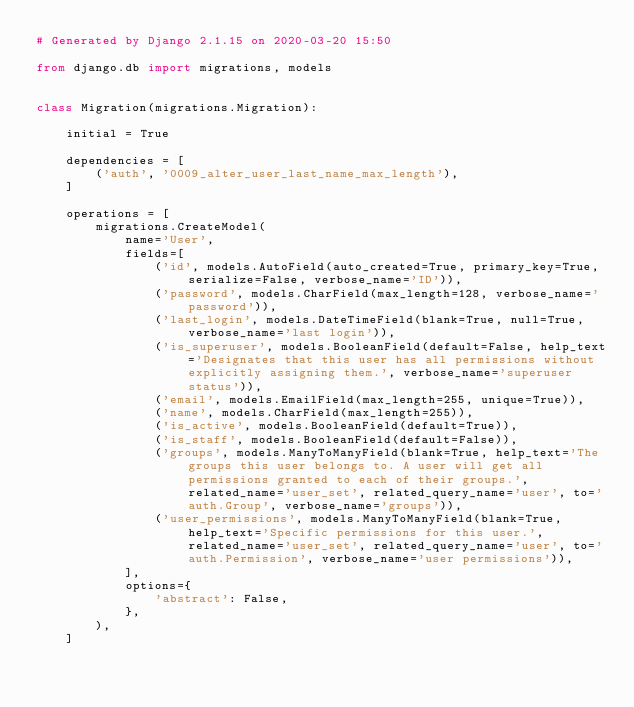<code> <loc_0><loc_0><loc_500><loc_500><_Python_># Generated by Django 2.1.15 on 2020-03-20 15:50

from django.db import migrations, models


class Migration(migrations.Migration):

    initial = True

    dependencies = [
        ('auth', '0009_alter_user_last_name_max_length'),
    ]

    operations = [
        migrations.CreateModel(
            name='User',
            fields=[
                ('id', models.AutoField(auto_created=True, primary_key=True, serialize=False, verbose_name='ID')),
                ('password', models.CharField(max_length=128, verbose_name='password')),
                ('last_login', models.DateTimeField(blank=True, null=True, verbose_name='last login')),
                ('is_superuser', models.BooleanField(default=False, help_text='Designates that this user has all permissions without explicitly assigning them.', verbose_name='superuser status')),
                ('email', models.EmailField(max_length=255, unique=True)),
                ('name', models.CharField(max_length=255)),
                ('is_active', models.BooleanField(default=True)),
                ('is_staff', models.BooleanField(default=False)),
                ('groups', models.ManyToManyField(blank=True, help_text='The groups this user belongs to. A user will get all permissions granted to each of their groups.', related_name='user_set', related_query_name='user', to='auth.Group', verbose_name='groups')),
                ('user_permissions', models.ManyToManyField(blank=True, help_text='Specific permissions for this user.', related_name='user_set', related_query_name='user', to='auth.Permission', verbose_name='user permissions')),
            ],
            options={
                'abstract': False,
            },
        ),
    ]
</code> 